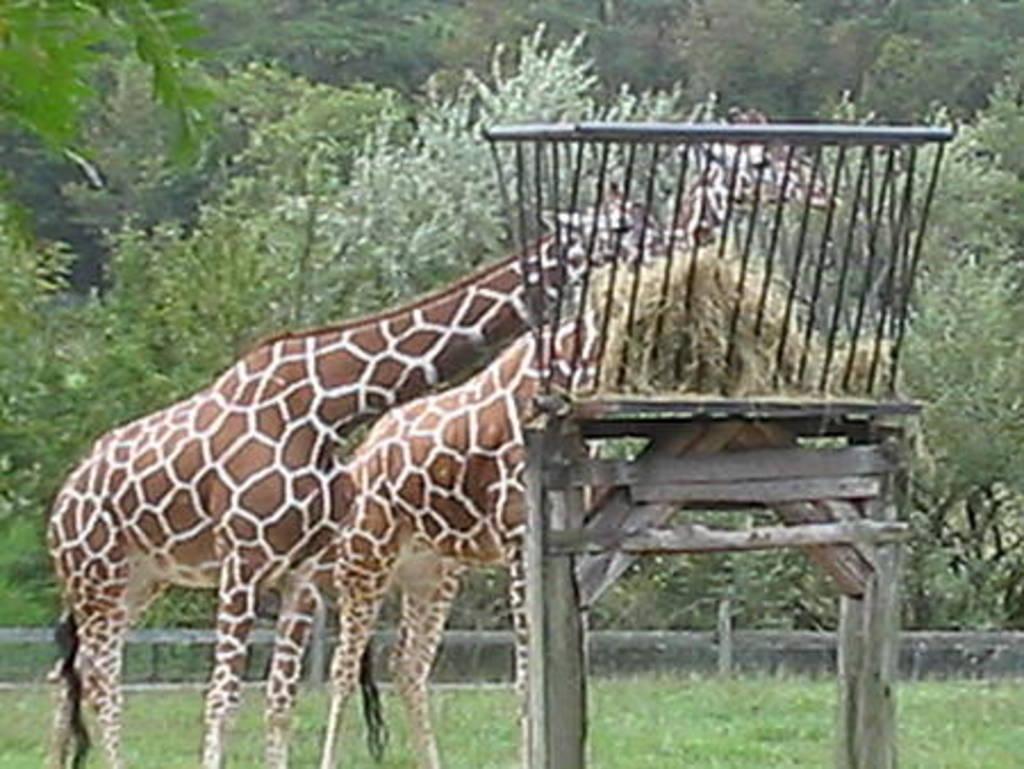What animals are in the center of the image? There are giraffes in the center of the image. Where is the basket located in the image? The basket is placed on a table on the right side of the image. What can be seen in the background of the image? There are trees in the background of the image. What type of vegetation is visible at the bottom of the image? There is grass visible at the bottom of the image. How does the sofa control the giraffes in the image? There is no sofa present in the image, and the giraffes are not being controlled by any object or person. 